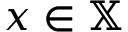<formula> <loc_0><loc_0><loc_500><loc_500>x \in \mathbb { X }</formula> 